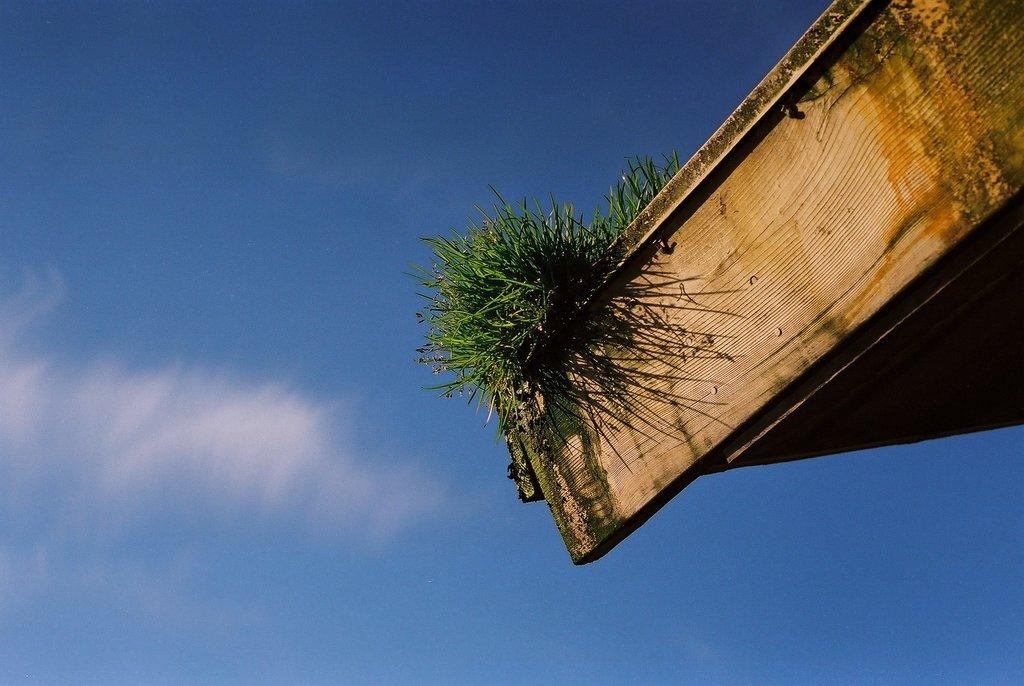What type of object is located on the right side of the image? There is a wooden object on the right side of the image. What is covering the wooden object? Grass is visible on the wooden object. What can be seen in the background of the image? There are clouds and the sky visible in the background of the image. How many parcels are being delivered in the image? There are no parcels or delivery activity depicted in the image. What type of cloud is present in the image? The provided facts do not specify the type of cloud; only that clouds are visible in the background. 